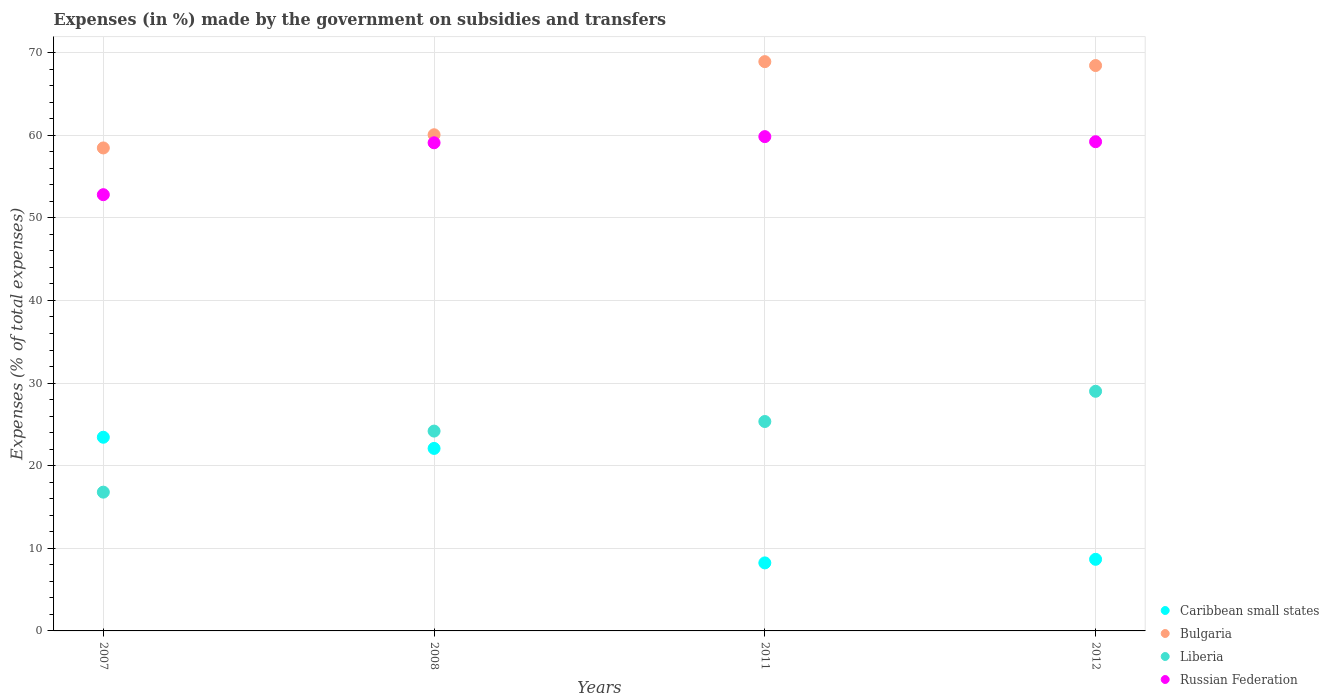Is the number of dotlines equal to the number of legend labels?
Your answer should be very brief. Yes. What is the percentage of expenses made by the government on subsidies and transfers in Russian Federation in 2012?
Make the answer very short. 59.21. Across all years, what is the maximum percentage of expenses made by the government on subsidies and transfers in Liberia?
Ensure brevity in your answer.  29. Across all years, what is the minimum percentage of expenses made by the government on subsidies and transfers in Bulgaria?
Make the answer very short. 58.45. In which year was the percentage of expenses made by the government on subsidies and transfers in Bulgaria maximum?
Make the answer very short. 2011. In which year was the percentage of expenses made by the government on subsidies and transfers in Liberia minimum?
Offer a very short reply. 2007. What is the total percentage of expenses made by the government on subsidies and transfers in Liberia in the graph?
Offer a terse response. 95.33. What is the difference between the percentage of expenses made by the government on subsidies and transfers in Russian Federation in 2007 and that in 2008?
Offer a terse response. -6.28. What is the difference between the percentage of expenses made by the government on subsidies and transfers in Bulgaria in 2012 and the percentage of expenses made by the government on subsidies and transfers in Caribbean small states in 2007?
Your answer should be compact. 44.99. What is the average percentage of expenses made by the government on subsidies and transfers in Liberia per year?
Make the answer very short. 23.83. In the year 2012, what is the difference between the percentage of expenses made by the government on subsidies and transfers in Liberia and percentage of expenses made by the government on subsidies and transfers in Bulgaria?
Make the answer very short. -39.43. In how many years, is the percentage of expenses made by the government on subsidies and transfers in Caribbean small states greater than 12 %?
Provide a short and direct response. 2. What is the ratio of the percentage of expenses made by the government on subsidies and transfers in Russian Federation in 2008 to that in 2011?
Your response must be concise. 0.99. Is the percentage of expenses made by the government on subsidies and transfers in Russian Federation in 2007 less than that in 2012?
Provide a short and direct response. Yes. Is the difference between the percentage of expenses made by the government on subsidies and transfers in Liberia in 2007 and 2012 greater than the difference between the percentage of expenses made by the government on subsidies and transfers in Bulgaria in 2007 and 2012?
Give a very brief answer. No. What is the difference between the highest and the second highest percentage of expenses made by the government on subsidies and transfers in Russian Federation?
Ensure brevity in your answer.  0.62. What is the difference between the highest and the lowest percentage of expenses made by the government on subsidies and transfers in Russian Federation?
Offer a very short reply. 7.03. Is the sum of the percentage of expenses made by the government on subsidies and transfers in Russian Federation in 2007 and 2011 greater than the maximum percentage of expenses made by the government on subsidies and transfers in Bulgaria across all years?
Keep it short and to the point. Yes. Is it the case that in every year, the sum of the percentage of expenses made by the government on subsidies and transfers in Caribbean small states and percentage of expenses made by the government on subsidies and transfers in Bulgaria  is greater than the percentage of expenses made by the government on subsidies and transfers in Liberia?
Your response must be concise. Yes. Does the percentage of expenses made by the government on subsidies and transfers in Bulgaria monotonically increase over the years?
Ensure brevity in your answer.  No. Is the percentage of expenses made by the government on subsidies and transfers in Caribbean small states strictly less than the percentage of expenses made by the government on subsidies and transfers in Liberia over the years?
Keep it short and to the point. No. How many dotlines are there?
Give a very brief answer. 4. How many years are there in the graph?
Your response must be concise. 4. What is the difference between two consecutive major ticks on the Y-axis?
Your response must be concise. 10. Does the graph contain grids?
Provide a short and direct response. Yes. What is the title of the graph?
Provide a short and direct response. Expenses (in %) made by the government on subsidies and transfers. Does "Dominican Republic" appear as one of the legend labels in the graph?
Your answer should be compact. No. What is the label or title of the Y-axis?
Your response must be concise. Expenses (% of total expenses). What is the Expenses (% of total expenses) of Caribbean small states in 2007?
Provide a succinct answer. 23.44. What is the Expenses (% of total expenses) in Bulgaria in 2007?
Keep it short and to the point. 58.45. What is the Expenses (% of total expenses) in Liberia in 2007?
Ensure brevity in your answer.  16.8. What is the Expenses (% of total expenses) of Russian Federation in 2007?
Make the answer very short. 52.8. What is the Expenses (% of total expenses) in Caribbean small states in 2008?
Your answer should be very brief. 22.09. What is the Expenses (% of total expenses) of Bulgaria in 2008?
Your response must be concise. 60.05. What is the Expenses (% of total expenses) of Liberia in 2008?
Give a very brief answer. 24.19. What is the Expenses (% of total expenses) of Russian Federation in 2008?
Your answer should be compact. 59.08. What is the Expenses (% of total expenses) of Caribbean small states in 2011?
Your response must be concise. 8.23. What is the Expenses (% of total expenses) in Bulgaria in 2011?
Provide a succinct answer. 68.9. What is the Expenses (% of total expenses) of Liberia in 2011?
Keep it short and to the point. 25.34. What is the Expenses (% of total expenses) in Russian Federation in 2011?
Make the answer very short. 59.83. What is the Expenses (% of total expenses) of Caribbean small states in 2012?
Keep it short and to the point. 8.67. What is the Expenses (% of total expenses) of Bulgaria in 2012?
Keep it short and to the point. 68.43. What is the Expenses (% of total expenses) of Liberia in 2012?
Keep it short and to the point. 29. What is the Expenses (% of total expenses) of Russian Federation in 2012?
Make the answer very short. 59.21. Across all years, what is the maximum Expenses (% of total expenses) of Caribbean small states?
Offer a terse response. 23.44. Across all years, what is the maximum Expenses (% of total expenses) in Bulgaria?
Keep it short and to the point. 68.9. Across all years, what is the maximum Expenses (% of total expenses) in Liberia?
Provide a short and direct response. 29. Across all years, what is the maximum Expenses (% of total expenses) of Russian Federation?
Provide a short and direct response. 59.83. Across all years, what is the minimum Expenses (% of total expenses) of Caribbean small states?
Your answer should be compact. 8.23. Across all years, what is the minimum Expenses (% of total expenses) in Bulgaria?
Provide a succinct answer. 58.45. Across all years, what is the minimum Expenses (% of total expenses) of Liberia?
Offer a very short reply. 16.8. Across all years, what is the minimum Expenses (% of total expenses) in Russian Federation?
Your response must be concise. 52.8. What is the total Expenses (% of total expenses) of Caribbean small states in the graph?
Keep it short and to the point. 62.43. What is the total Expenses (% of total expenses) of Bulgaria in the graph?
Keep it short and to the point. 255.84. What is the total Expenses (% of total expenses) of Liberia in the graph?
Provide a succinct answer. 95.33. What is the total Expenses (% of total expenses) of Russian Federation in the graph?
Your answer should be compact. 230.91. What is the difference between the Expenses (% of total expenses) in Caribbean small states in 2007 and that in 2008?
Your answer should be compact. 1.35. What is the difference between the Expenses (% of total expenses) in Bulgaria in 2007 and that in 2008?
Provide a succinct answer. -1.6. What is the difference between the Expenses (% of total expenses) in Liberia in 2007 and that in 2008?
Provide a succinct answer. -7.39. What is the difference between the Expenses (% of total expenses) of Russian Federation in 2007 and that in 2008?
Your answer should be very brief. -6.28. What is the difference between the Expenses (% of total expenses) of Caribbean small states in 2007 and that in 2011?
Ensure brevity in your answer.  15.21. What is the difference between the Expenses (% of total expenses) in Bulgaria in 2007 and that in 2011?
Provide a short and direct response. -10.45. What is the difference between the Expenses (% of total expenses) of Liberia in 2007 and that in 2011?
Give a very brief answer. -8.55. What is the difference between the Expenses (% of total expenses) in Russian Federation in 2007 and that in 2011?
Give a very brief answer. -7.03. What is the difference between the Expenses (% of total expenses) in Caribbean small states in 2007 and that in 2012?
Provide a short and direct response. 14.77. What is the difference between the Expenses (% of total expenses) in Bulgaria in 2007 and that in 2012?
Offer a very short reply. -9.97. What is the difference between the Expenses (% of total expenses) in Liberia in 2007 and that in 2012?
Keep it short and to the point. -12.21. What is the difference between the Expenses (% of total expenses) in Russian Federation in 2007 and that in 2012?
Provide a succinct answer. -6.41. What is the difference between the Expenses (% of total expenses) of Caribbean small states in 2008 and that in 2011?
Make the answer very short. 13.85. What is the difference between the Expenses (% of total expenses) in Bulgaria in 2008 and that in 2011?
Make the answer very short. -8.85. What is the difference between the Expenses (% of total expenses) in Liberia in 2008 and that in 2011?
Your answer should be compact. -1.16. What is the difference between the Expenses (% of total expenses) in Russian Federation in 2008 and that in 2011?
Keep it short and to the point. -0.74. What is the difference between the Expenses (% of total expenses) of Caribbean small states in 2008 and that in 2012?
Your answer should be very brief. 13.42. What is the difference between the Expenses (% of total expenses) in Bulgaria in 2008 and that in 2012?
Offer a terse response. -8.38. What is the difference between the Expenses (% of total expenses) in Liberia in 2008 and that in 2012?
Provide a short and direct response. -4.82. What is the difference between the Expenses (% of total expenses) in Russian Federation in 2008 and that in 2012?
Provide a succinct answer. -0.13. What is the difference between the Expenses (% of total expenses) in Caribbean small states in 2011 and that in 2012?
Keep it short and to the point. -0.43. What is the difference between the Expenses (% of total expenses) of Bulgaria in 2011 and that in 2012?
Provide a succinct answer. 0.47. What is the difference between the Expenses (% of total expenses) in Liberia in 2011 and that in 2012?
Make the answer very short. -3.66. What is the difference between the Expenses (% of total expenses) in Russian Federation in 2011 and that in 2012?
Your answer should be very brief. 0.62. What is the difference between the Expenses (% of total expenses) in Caribbean small states in 2007 and the Expenses (% of total expenses) in Bulgaria in 2008?
Your response must be concise. -36.61. What is the difference between the Expenses (% of total expenses) of Caribbean small states in 2007 and the Expenses (% of total expenses) of Liberia in 2008?
Offer a terse response. -0.75. What is the difference between the Expenses (% of total expenses) of Caribbean small states in 2007 and the Expenses (% of total expenses) of Russian Federation in 2008?
Offer a very short reply. -35.64. What is the difference between the Expenses (% of total expenses) of Bulgaria in 2007 and the Expenses (% of total expenses) of Liberia in 2008?
Offer a very short reply. 34.27. What is the difference between the Expenses (% of total expenses) in Bulgaria in 2007 and the Expenses (% of total expenses) in Russian Federation in 2008?
Provide a short and direct response. -0.63. What is the difference between the Expenses (% of total expenses) of Liberia in 2007 and the Expenses (% of total expenses) of Russian Federation in 2008?
Provide a succinct answer. -42.29. What is the difference between the Expenses (% of total expenses) in Caribbean small states in 2007 and the Expenses (% of total expenses) in Bulgaria in 2011?
Your response must be concise. -45.46. What is the difference between the Expenses (% of total expenses) in Caribbean small states in 2007 and the Expenses (% of total expenses) in Liberia in 2011?
Your response must be concise. -1.9. What is the difference between the Expenses (% of total expenses) of Caribbean small states in 2007 and the Expenses (% of total expenses) of Russian Federation in 2011?
Your answer should be very brief. -36.38. What is the difference between the Expenses (% of total expenses) of Bulgaria in 2007 and the Expenses (% of total expenses) of Liberia in 2011?
Provide a succinct answer. 33.11. What is the difference between the Expenses (% of total expenses) of Bulgaria in 2007 and the Expenses (% of total expenses) of Russian Federation in 2011?
Your answer should be compact. -1.37. What is the difference between the Expenses (% of total expenses) in Liberia in 2007 and the Expenses (% of total expenses) in Russian Federation in 2011?
Offer a very short reply. -43.03. What is the difference between the Expenses (% of total expenses) of Caribbean small states in 2007 and the Expenses (% of total expenses) of Bulgaria in 2012?
Provide a succinct answer. -44.99. What is the difference between the Expenses (% of total expenses) in Caribbean small states in 2007 and the Expenses (% of total expenses) in Liberia in 2012?
Your answer should be compact. -5.56. What is the difference between the Expenses (% of total expenses) of Caribbean small states in 2007 and the Expenses (% of total expenses) of Russian Federation in 2012?
Offer a very short reply. -35.77. What is the difference between the Expenses (% of total expenses) of Bulgaria in 2007 and the Expenses (% of total expenses) of Liberia in 2012?
Offer a very short reply. 29.45. What is the difference between the Expenses (% of total expenses) in Bulgaria in 2007 and the Expenses (% of total expenses) in Russian Federation in 2012?
Provide a short and direct response. -0.76. What is the difference between the Expenses (% of total expenses) of Liberia in 2007 and the Expenses (% of total expenses) of Russian Federation in 2012?
Ensure brevity in your answer.  -42.41. What is the difference between the Expenses (% of total expenses) in Caribbean small states in 2008 and the Expenses (% of total expenses) in Bulgaria in 2011?
Ensure brevity in your answer.  -46.81. What is the difference between the Expenses (% of total expenses) in Caribbean small states in 2008 and the Expenses (% of total expenses) in Liberia in 2011?
Provide a succinct answer. -3.26. What is the difference between the Expenses (% of total expenses) of Caribbean small states in 2008 and the Expenses (% of total expenses) of Russian Federation in 2011?
Make the answer very short. -37.74. What is the difference between the Expenses (% of total expenses) of Bulgaria in 2008 and the Expenses (% of total expenses) of Liberia in 2011?
Offer a terse response. 34.71. What is the difference between the Expenses (% of total expenses) in Bulgaria in 2008 and the Expenses (% of total expenses) in Russian Federation in 2011?
Offer a terse response. 0.23. What is the difference between the Expenses (% of total expenses) of Liberia in 2008 and the Expenses (% of total expenses) of Russian Federation in 2011?
Your answer should be very brief. -35.64. What is the difference between the Expenses (% of total expenses) of Caribbean small states in 2008 and the Expenses (% of total expenses) of Bulgaria in 2012?
Ensure brevity in your answer.  -46.34. What is the difference between the Expenses (% of total expenses) of Caribbean small states in 2008 and the Expenses (% of total expenses) of Liberia in 2012?
Your response must be concise. -6.91. What is the difference between the Expenses (% of total expenses) in Caribbean small states in 2008 and the Expenses (% of total expenses) in Russian Federation in 2012?
Your response must be concise. -37.12. What is the difference between the Expenses (% of total expenses) in Bulgaria in 2008 and the Expenses (% of total expenses) in Liberia in 2012?
Keep it short and to the point. 31.05. What is the difference between the Expenses (% of total expenses) of Bulgaria in 2008 and the Expenses (% of total expenses) of Russian Federation in 2012?
Keep it short and to the point. 0.84. What is the difference between the Expenses (% of total expenses) in Liberia in 2008 and the Expenses (% of total expenses) in Russian Federation in 2012?
Keep it short and to the point. -35.02. What is the difference between the Expenses (% of total expenses) of Caribbean small states in 2011 and the Expenses (% of total expenses) of Bulgaria in 2012?
Offer a terse response. -60.2. What is the difference between the Expenses (% of total expenses) of Caribbean small states in 2011 and the Expenses (% of total expenses) of Liberia in 2012?
Your answer should be compact. -20.77. What is the difference between the Expenses (% of total expenses) of Caribbean small states in 2011 and the Expenses (% of total expenses) of Russian Federation in 2012?
Your answer should be compact. -50.98. What is the difference between the Expenses (% of total expenses) in Bulgaria in 2011 and the Expenses (% of total expenses) in Liberia in 2012?
Your answer should be compact. 39.9. What is the difference between the Expenses (% of total expenses) in Bulgaria in 2011 and the Expenses (% of total expenses) in Russian Federation in 2012?
Offer a very short reply. 9.69. What is the difference between the Expenses (% of total expenses) in Liberia in 2011 and the Expenses (% of total expenses) in Russian Federation in 2012?
Offer a very short reply. -33.86. What is the average Expenses (% of total expenses) of Caribbean small states per year?
Give a very brief answer. 15.61. What is the average Expenses (% of total expenses) of Bulgaria per year?
Your answer should be very brief. 63.96. What is the average Expenses (% of total expenses) of Liberia per year?
Give a very brief answer. 23.83. What is the average Expenses (% of total expenses) of Russian Federation per year?
Keep it short and to the point. 57.73. In the year 2007, what is the difference between the Expenses (% of total expenses) in Caribbean small states and Expenses (% of total expenses) in Bulgaria?
Offer a very short reply. -35.01. In the year 2007, what is the difference between the Expenses (% of total expenses) of Caribbean small states and Expenses (% of total expenses) of Liberia?
Give a very brief answer. 6.65. In the year 2007, what is the difference between the Expenses (% of total expenses) in Caribbean small states and Expenses (% of total expenses) in Russian Federation?
Give a very brief answer. -29.36. In the year 2007, what is the difference between the Expenses (% of total expenses) of Bulgaria and Expenses (% of total expenses) of Liberia?
Make the answer very short. 41.66. In the year 2007, what is the difference between the Expenses (% of total expenses) in Bulgaria and Expenses (% of total expenses) in Russian Federation?
Make the answer very short. 5.66. In the year 2007, what is the difference between the Expenses (% of total expenses) in Liberia and Expenses (% of total expenses) in Russian Federation?
Provide a short and direct response. -36. In the year 2008, what is the difference between the Expenses (% of total expenses) in Caribbean small states and Expenses (% of total expenses) in Bulgaria?
Offer a terse response. -37.96. In the year 2008, what is the difference between the Expenses (% of total expenses) of Caribbean small states and Expenses (% of total expenses) of Liberia?
Give a very brief answer. -2.1. In the year 2008, what is the difference between the Expenses (% of total expenses) of Caribbean small states and Expenses (% of total expenses) of Russian Federation?
Make the answer very short. -36.99. In the year 2008, what is the difference between the Expenses (% of total expenses) of Bulgaria and Expenses (% of total expenses) of Liberia?
Your answer should be compact. 35.87. In the year 2008, what is the difference between the Expenses (% of total expenses) of Bulgaria and Expenses (% of total expenses) of Russian Federation?
Offer a very short reply. 0.97. In the year 2008, what is the difference between the Expenses (% of total expenses) of Liberia and Expenses (% of total expenses) of Russian Federation?
Make the answer very short. -34.9. In the year 2011, what is the difference between the Expenses (% of total expenses) in Caribbean small states and Expenses (% of total expenses) in Bulgaria?
Provide a short and direct response. -60.67. In the year 2011, what is the difference between the Expenses (% of total expenses) in Caribbean small states and Expenses (% of total expenses) in Liberia?
Give a very brief answer. -17.11. In the year 2011, what is the difference between the Expenses (% of total expenses) of Caribbean small states and Expenses (% of total expenses) of Russian Federation?
Offer a terse response. -51.59. In the year 2011, what is the difference between the Expenses (% of total expenses) of Bulgaria and Expenses (% of total expenses) of Liberia?
Make the answer very short. 43.56. In the year 2011, what is the difference between the Expenses (% of total expenses) in Bulgaria and Expenses (% of total expenses) in Russian Federation?
Keep it short and to the point. 9.08. In the year 2011, what is the difference between the Expenses (% of total expenses) of Liberia and Expenses (% of total expenses) of Russian Federation?
Your answer should be very brief. -34.48. In the year 2012, what is the difference between the Expenses (% of total expenses) in Caribbean small states and Expenses (% of total expenses) in Bulgaria?
Give a very brief answer. -59.76. In the year 2012, what is the difference between the Expenses (% of total expenses) in Caribbean small states and Expenses (% of total expenses) in Liberia?
Ensure brevity in your answer.  -20.34. In the year 2012, what is the difference between the Expenses (% of total expenses) in Caribbean small states and Expenses (% of total expenses) in Russian Federation?
Your response must be concise. -50.54. In the year 2012, what is the difference between the Expenses (% of total expenses) in Bulgaria and Expenses (% of total expenses) in Liberia?
Offer a very short reply. 39.43. In the year 2012, what is the difference between the Expenses (% of total expenses) of Bulgaria and Expenses (% of total expenses) of Russian Federation?
Provide a short and direct response. 9.22. In the year 2012, what is the difference between the Expenses (% of total expenses) in Liberia and Expenses (% of total expenses) in Russian Federation?
Make the answer very short. -30.21. What is the ratio of the Expenses (% of total expenses) of Caribbean small states in 2007 to that in 2008?
Keep it short and to the point. 1.06. What is the ratio of the Expenses (% of total expenses) of Bulgaria in 2007 to that in 2008?
Your answer should be very brief. 0.97. What is the ratio of the Expenses (% of total expenses) of Liberia in 2007 to that in 2008?
Your response must be concise. 0.69. What is the ratio of the Expenses (% of total expenses) of Russian Federation in 2007 to that in 2008?
Your answer should be very brief. 0.89. What is the ratio of the Expenses (% of total expenses) of Caribbean small states in 2007 to that in 2011?
Make the answer very short. 2.85. What is the ratio of the Expenses (% of total expenses) in Bulgaria in 2007 to that in 2011?
Ensure brevity in your answer.  0.85. What is the ratio of the Expenses (% of total expenses) in Liberia in 2007 to that in 2011?
Provide a short and direct response. 0.66. What is the ratio of the Expenses (% of total expenses) of Russian Federation in 2007 to that in 2011?
Give a very brief answer. 0.88. What is the ratio of the Expenses (% of total expenses) of Caribbean small states in 2007 to that in 2012?
Provide a succinct answer. 2.7. What is the ratio of the Expenses (% of total expenses) of Bulgaria in 2007 to that in 2012?
Offer a terse response. 0.85. What is the ratio of the Expenses (% of total expenses) of Liberia in 2007 to that in 2012?
Ensure brevity in your answer.  0.58. What is the ratio of the Expenses (% of total expenses) in Russian Federation in 2007 to that in 2012?
Provide a succinct answer. 0.89. What is the ratio of the Expenses (% of total expenses) of Caribbean small states in 2008 to that in 2011?
Provide a succinct answer. 2.68. What is the ratio of the Expenses (% of total expenses) in Bulgaria in 2008 to that in 2011?
Your answer should be compact. 0.87. What is the ratio of the Expenses (% of total expenses) of Liberia in 2008 to that in 2011?
Your answer should be very brief. 0.95. What is the ratio of the Expenses (% of total expenses) of Russian Federation in 2008 to that in 2011?
Provide a succinct answer. 0.99. What is the ratio of the Expenses (% of total expenses) of Caribbean small states in 2008 to that in 2012?
Make the answer very short. 2.55. What is the ratio of the Expenses (% of total expenses) in Bulgaria in 2008 to that in 2012?
Make the answer very short. 0.88. What is the ratio of the Expenses (% of total expenses) of Liberia in 2008 to that in 2012?
Provide a succinct answer. 0.83. What is the ratio of the Expenses (% of total expenses) of Caribbean small states in 2011 to that in 2012?
Your answer should be very brief. 0.95. What is the ratio of the Expenses (% of total expenses) in Bulgaria in 2011 to that in 2012?
Provide a succinct answer. 1.01. What is the ratio of the Expenses (% of total expenses) of Liberia in 2011 to that in 2012?
Ensure brevity in your answer.  0.87. What is the ratio of the Expenses (% of total expenses) of Russian Federation in 2011 to that in 2012?
Keep it short and to the point. 1.01. What is the difference between the highest and the second highest Expenses (% of total expenses) of Caribbean small states?
Give a very brief answer. 1.35. What is the difference between the highest and the second highest Expenses (% of total expenses) of Bulgaria?
Provide a succinct answer. 0.47. What is the difference between the highest and the second highest Expenses (% of total expenses) in Liberia?
Your answer should be compact. 3.66. What is the difference between the highest and the second highest Expenses (% of total expenses) in Russian Federation?
Provide a short and direct response. 0.62. What is the difference between the highest and the lowest Expenses (% of total expenses) of Caribbean small states?
Your response must be concise. 15.21. What is the difference between the highest and the lowest Expenses (% of total expenses) in Bulgaria?
Ensure brevity in your answer.  10.45. What is the difference between the highest and the lowest Expenses (% of total expenses) in Liberia?
Your answer should be compact. 12.21. What is the difference between the highest and the lowest Expenses (% of total expenses) of Russian Federation?
Your answer should be compact. 7.03. 